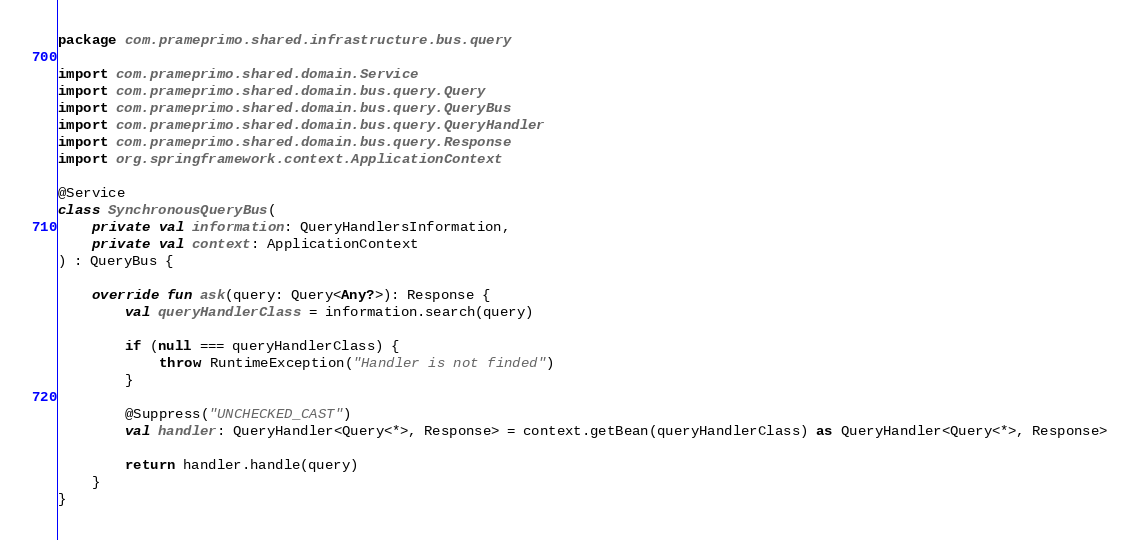<code> <loc_0><loc_0><loc_500><loc_500><_Kotlin_>package com.prameprimo.shared.infrastructure.bus.query

import com.prameprimo.shared.domain.Service
import com.prameprimo.shared.domain.bus.query.Query
import com.prameprimo.shared.domain.bus.query.QueryBus
import com.prameprimo.shared.domain.bus.query.QueryHandler
import com.prameprimo.shared.domain.bus.query.Response
import org.springframework.context.ApplicationContext

@Service
class SynchronousQueryBus(
    private val information: QueryHandlersInformation,
    private val context: ApplicationContext
) : QueryBus {

    override fun ask(query: Query<Any?>): Response {
        val queryHandlerClass = information.search(query)

        if (null === queryHandlerClass) {
            throw RuntimeException("Handler is not finded")
        }

        @Suppress("UNCHECKED_CAST")
        val handler: QueryHandler<Query<*>, Response> = context.getBean(queryHandlerClass) as QueryHandler<Query<*>, Response>

        return handler.handle(query)
    }
}</code> 